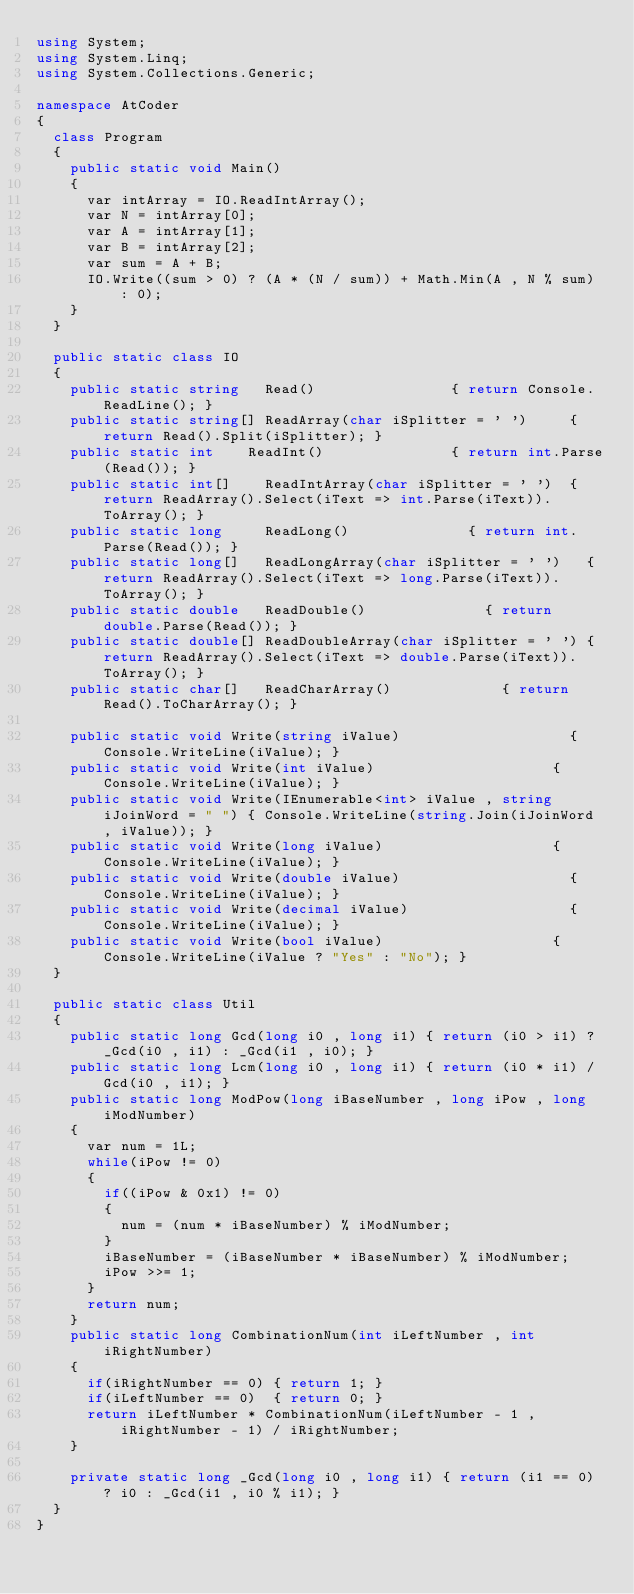<code> <loc_0><loc_0><loc_500><loc_500><_C#_>using System;
using System.Linq;
using System.Collections.Generic;

namespace AtCoder
{
	class Program
	{
		public static void Main()
		{
			var intArray = IO.ReadIntArray();
			var N = intArray[0];
			var A = intArray[1];
			var B = intArray[2];
			var sum = A + B;
			IO.Write((sum > 0) ? (A * (N / sum)) + Math.Min(A , N % sum) : 0);
		}
	}

	public static class IO
	{
		public static string   Read()								 { return Console.ReadLine(); }
		public static string[] ReadArray(char iSplitter = ' ')		 { return Read().Split(iSplitter); }
		public static int	   ReadInt()							 { return int.Parse(Read()); }
		public static int[]	   ReadIntArray(char iSplitter = ' ')	 { return ReadArray().Select(iText => int.Parse(iText)).ToArray(); }
		public static long	   ReadLong()							 { return int.Parse(Read()); }
		public static long[]   ReadLongArray(char iSplitter = ' ')	 { return ReadArray().Select(iText => long.Parse(iText)).ToArray(); }
		public static double   ReadDouble()							 { return double.Parse(Read()); }
		public static double[] ReadDoubleArray(char iSplitter = ' ') { return ReadArray().Select(iText => double.Parse(iText)).ToArray(); }
		public static char[]   ReadCharArray()						 { return Read().ToCharArray(); }

		public static void Write(string iValue)									   { Console.WriteLine(iValue); }
		public static void Write(int iValue)									   { Console.WriteLine(iValue); }
		public static void Write(IEnumerable<int> iValue , string iJoinWord = " ") { Console.WriteLine(string.Join(iJoinWord , iValue)); }
		public static void Write(long iValue)									   { Console.WriteLine(iValue); }
		public static void Write(double iValue)									   { Console.WriteLine(iValue); }
		public static void Write(decimal iValue)								   { Console.WriteLine(iValue); }
		public static void Write(bool iValue)									   { Console.WriteLine(iValue ? "Yes" : "No"); }
	}

	public static class Util
	{
		public static long Gcd(long i0 , long i1) { return (i0 > i1) ? _Gcd(i0 , i1) : _Gcd(i1 , i0); }
		public static long Lcm(long i0 , long i1) { return (i0 * i1) / Gcd(i0 , i1); }
		public static long ModPow(long iBaseNumber , long iPow , long iModNumber)
		{
			var num = 1L;
			while(iPow != 0)
			{
				if((iPow & 0x1) != 0)
				{
					num = (num * iBaseNumber) % iModNumber;
				}
				iBaseNumber = (iBaseNumber * iBaseNumber) % iModNumber;
				iPow >>= 1;
			}
			return num;
		}
		public static long CombinationNum(int iLeftNumber , int iRightNumber)
		{
			if(iRightNumber == 0) { return 1; }
			if(iLeftNumber == 0)  { return 0; }
			return iLeftNumber * CombinationNum(iLeftNumber - 1 , iRightNumber - 1) / iRightNumber;
		}

		private static long _Gcd(long i0 , long i1)	{ return (i1 == 0) ? i0 : _Gcd(i1 , i0 % i1); }
	}
}
</code> 